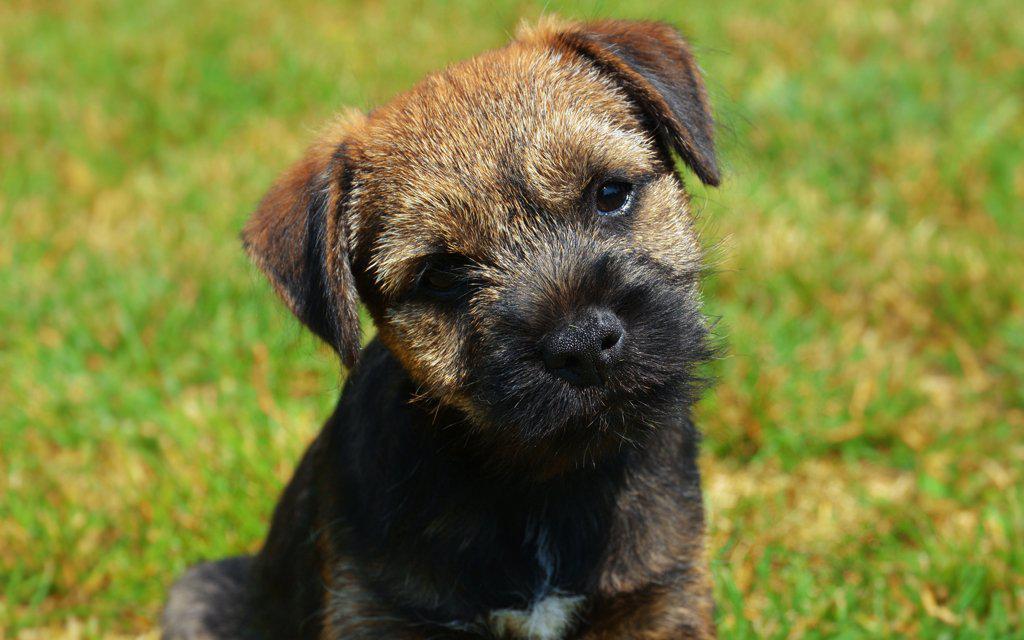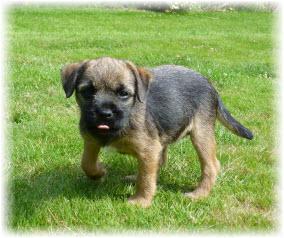The first image is the image on the left, the second image is the image on the right. Assess this claim about the two images: "The left image shows a dog standing with all four paws on the ground.". Correct or not? Answer yes or no. No. 